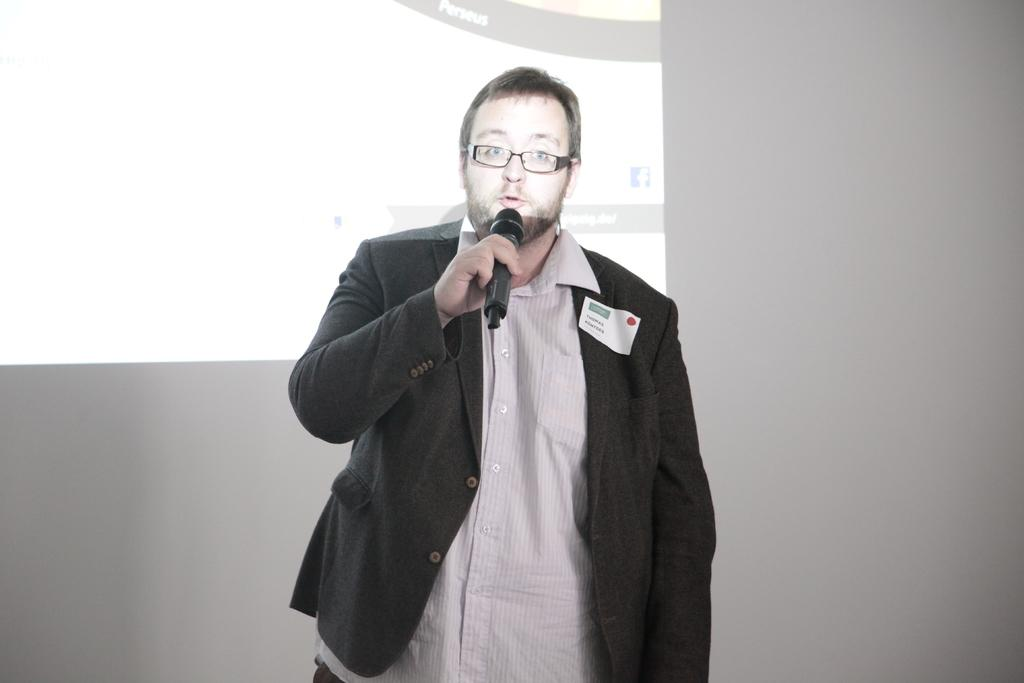Who is present in the image? There is a man in the image. What is the man doing in the image? The man is standing and speaking in the image. What is the man holding in his hand? The man is holding a mic in his hand. What can be seen on the wall in the background of the image? There is a projector display screen on the wall in the background. What type of ice can be seen melting on the furniture in the image? There is no ice or furniture present in the image. What advertisement is being displayed on the projector display screen in the image? The image does not provide information about the content being displayed on the projector display screen. 